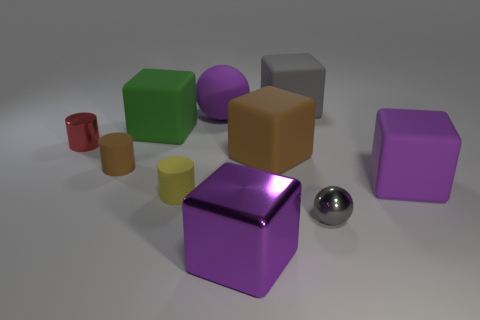Subtract all green cubes. How many cubes are left? 4 Subtract all shiny cubes. How many cubes are left? 4 Subtract all yellow blocks. Subtract all cyan spheres. How many blocks are left? 5 Subtract all balls. How many objects are left? 8 Add 6 big cyan objects. How many big cyan objects exist? 6 Subtract 2 purple cubes. How many objects are left? 8 Subtract all large cubes. Subtract all metal cylinders. How many objects are left? 4 Add 7 gray metal balls. How many gray metal balls are left? 8 